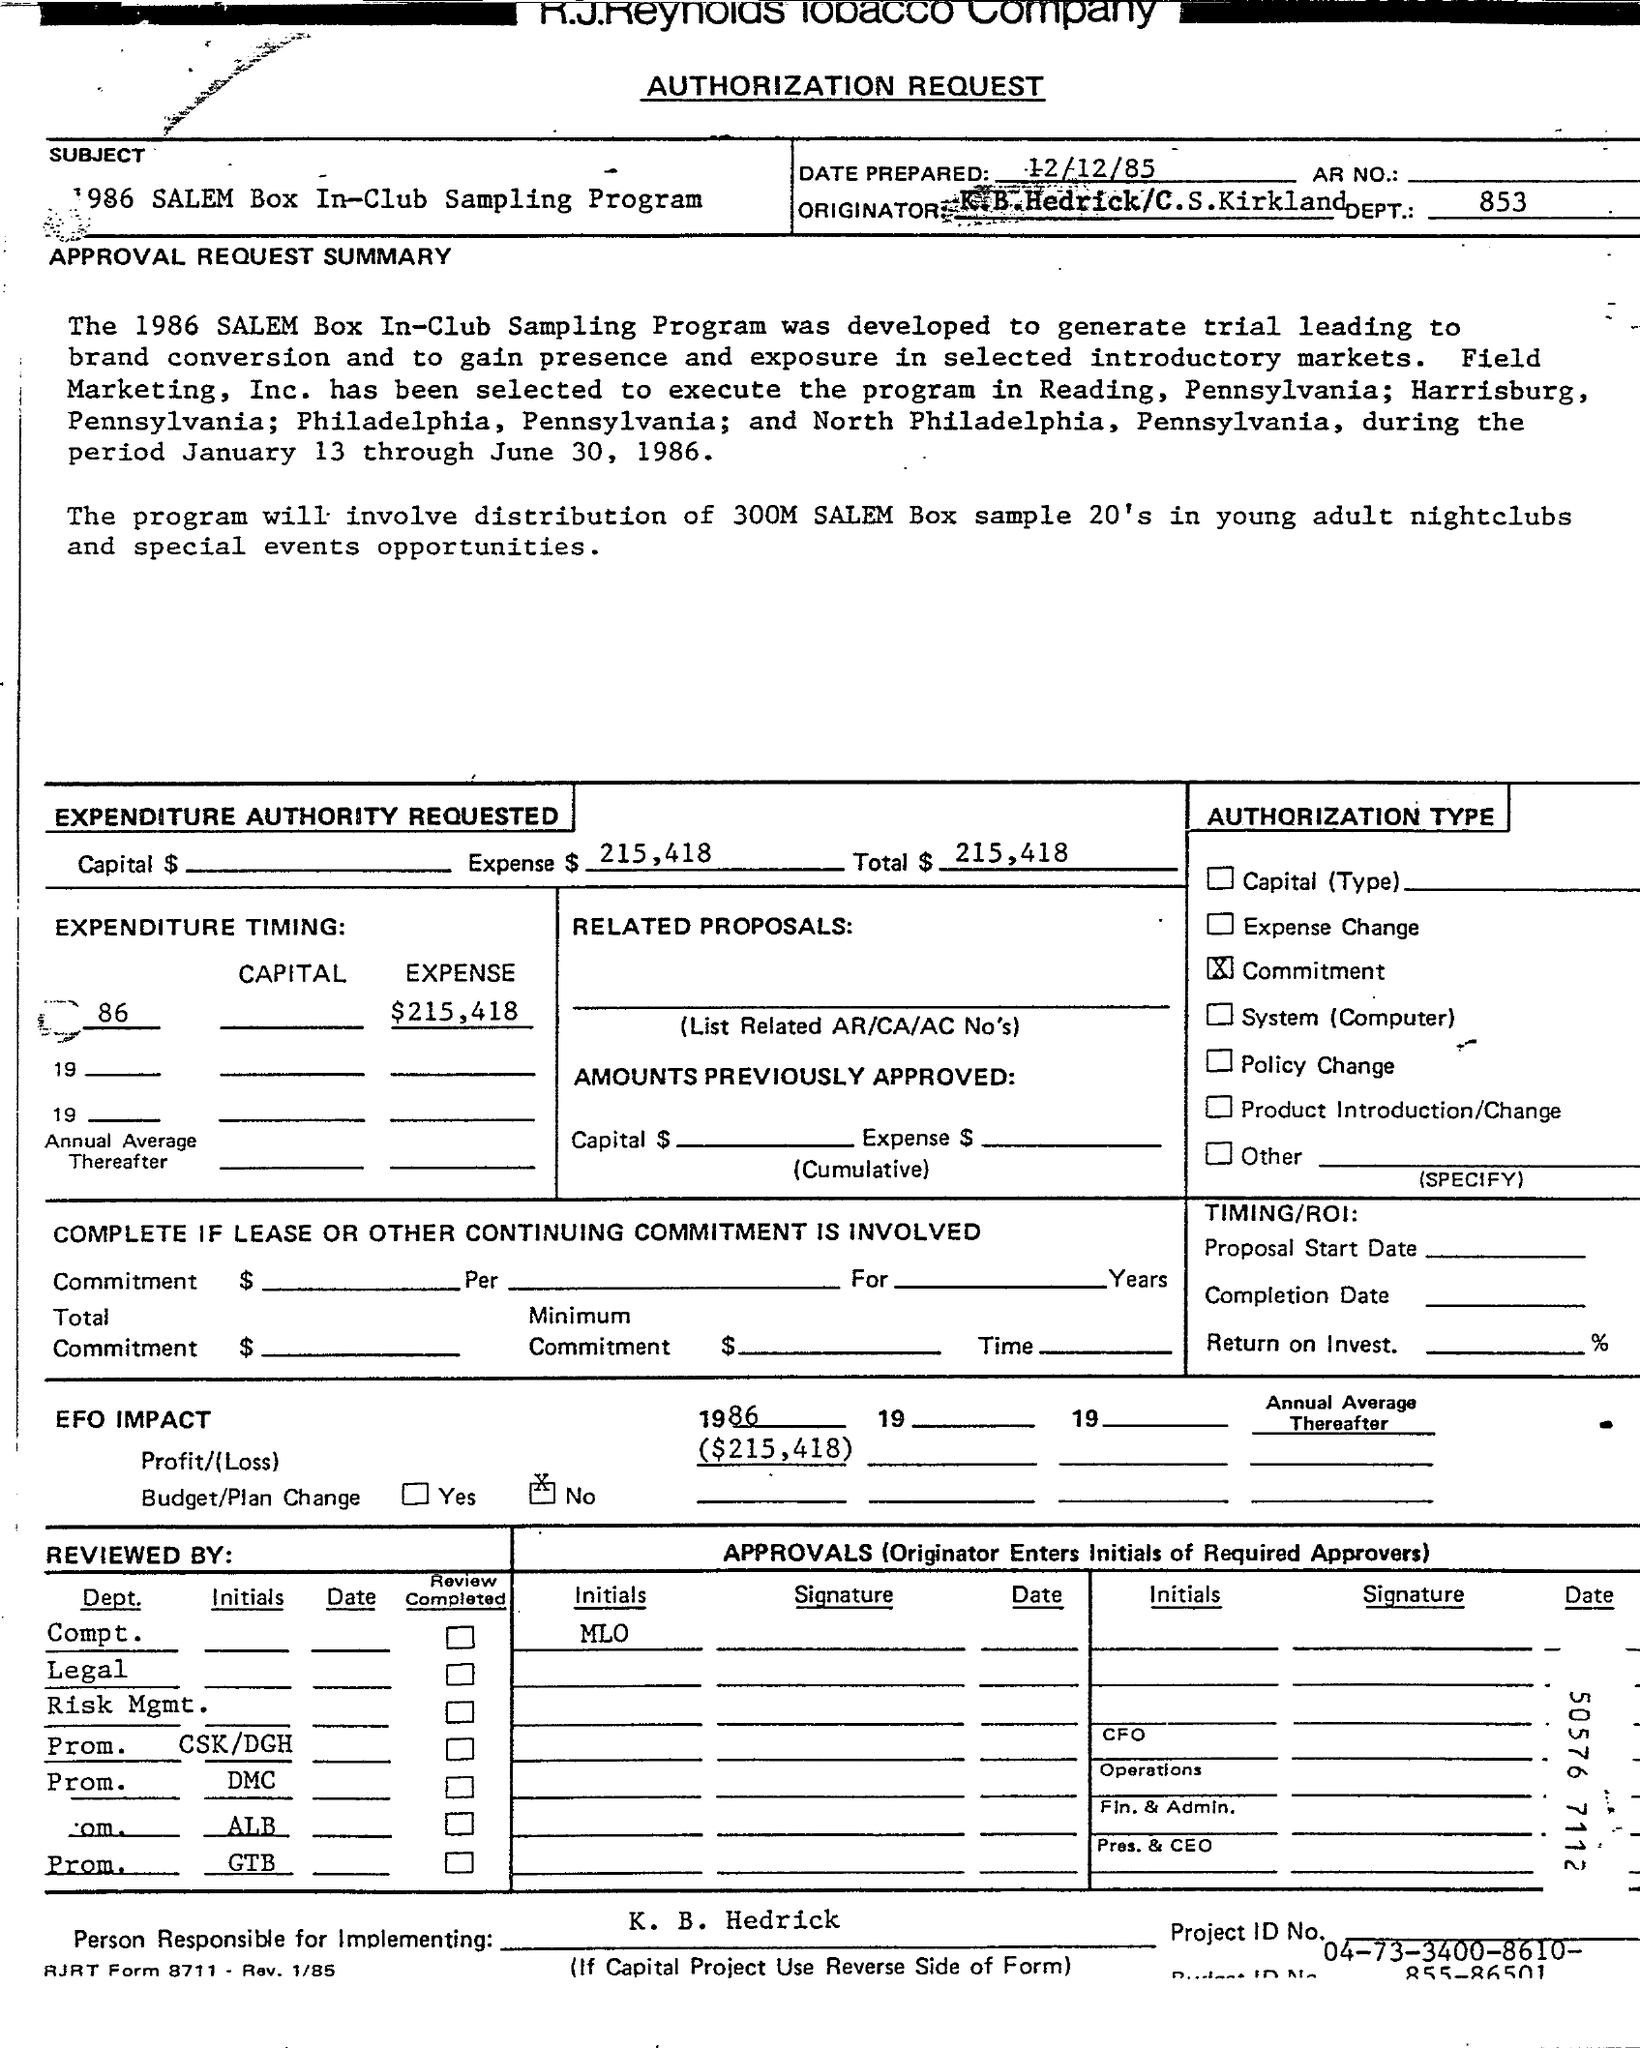What is the Title of the document?
Make the answer very short. Authorization Request. When is the Date Prepared?
Keep it short and to the point. 12/12/85. What is the Expense $?
Your answer should be compact. 215,418. Whta is the Total $?
Offer a terse response. 215,418. Who is the Person Responsible for Implementing?
Give a very brief answer. K. B. HEDRICK. 